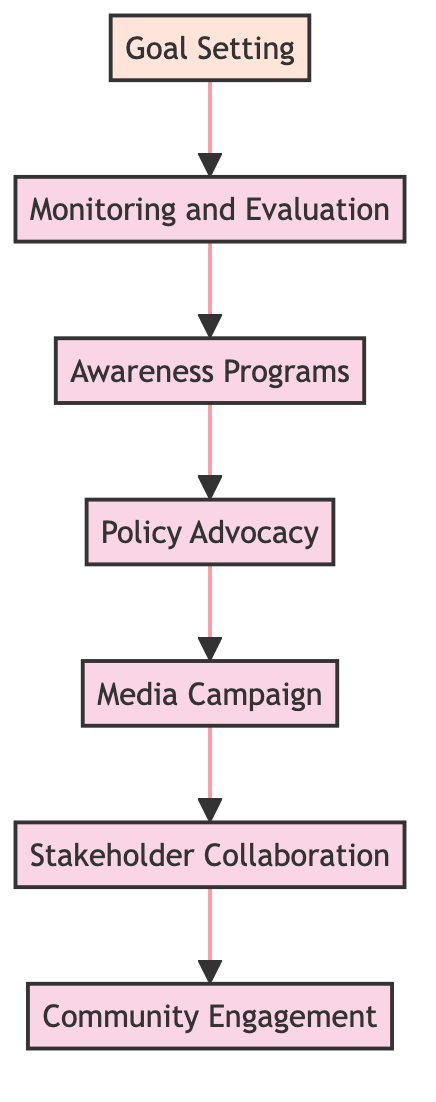What is the first step in the flow of the campaign? The first step, or the entry point in the flow, is "Goal Setting." This is the initial action that sets the direction and objectives for the entire campaign.
Answer: Goal Setting How many nodes are present in the diagram? Counting all the named elements including the goal, there are 7 nodes in total: Goal Setting, Monitoring and Evaluation, Awareness Programs, Policy Advocacy, Media Campaign, Stakeholder Collaboration, and Community Engagement.
Answer: 7 What is the last step of the campaign flow? The last step in the flow is "Community Engagement." It is positioned at the top of the flowchart and indicates the engagement of the community as a final action of the campaign.
Answer: Community Engagement What two steps are directly connected before "Media Campaign"? The steps directly connected before "Media Campaign" are "Policy Advocacy" and "Stakeholder Collaboration." They are sequentially linked, where "Policy Advocacy" leads to "Media Campaign."
Answer: Policy Advocacy, Stakeholder Collaboration Which step involves collaboration with outside entities? The step that involves collaboration with outside entities is "Stakeholder Collaboration." This step focuses on working with NGOs, educational institutions, and government agencies to enhance support and resources.
Answer: Stakeholder Collaboration What step follows "Awareness Programs"? Following "Awareness Programs," the next step in the flow is "Policy Advocacy." This indicates that awareness initiatives are directly tied to influencing policy changes for education rights.
Answer: Policy Advocacy What is the main purpose of "Monitoring and Evaluation"? The main purpose of "Monitoring and Evaluation" is to establish a system that assesses the impact and effectiveness of the campaign, allowing for necessary adjustments based on findings.
Answer: Assessing impact How do "Goal Setting" and "Monitoring and Evaluation" relate in the flow? "Goal Setting" is the foundational step that leads into "Monitoring and Evaluation," indicating that goals must be defined first to evaluate the progress and effectiveness of the campaigns accurately.
Answer: Sequentially linked 